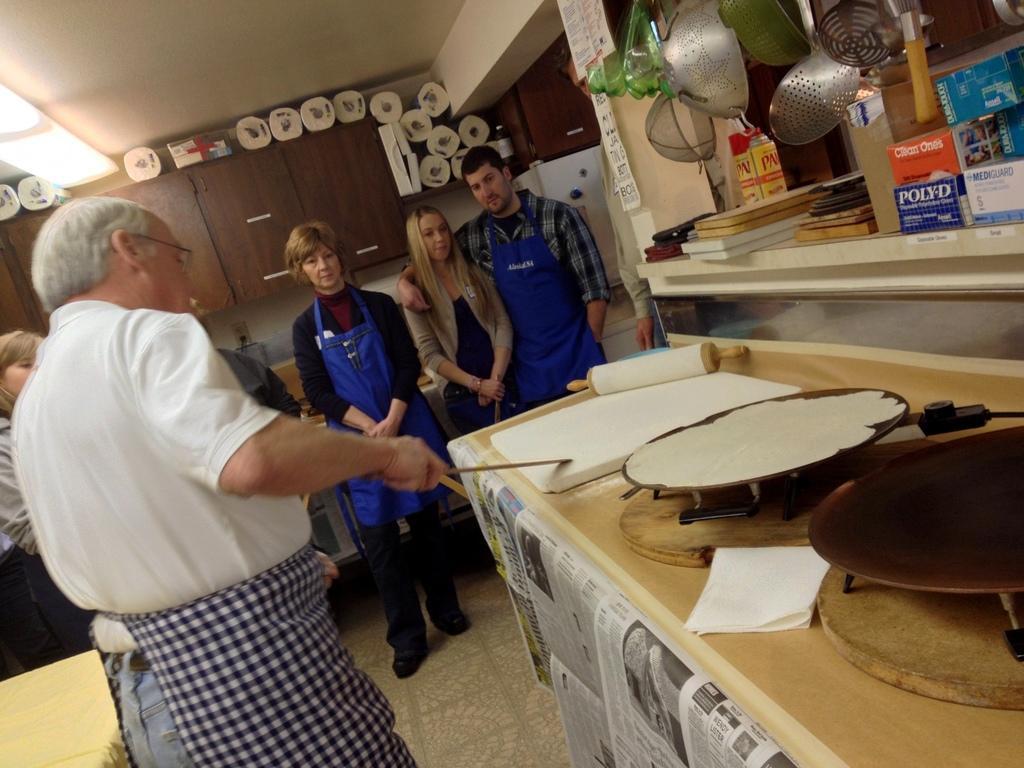Describe this image in one or two sentences. In this image ,in the middle there is a man who is standing and explaining the things to the people who are beside him. There are people wearing the cooking court. At the top there is light,cupboard and tissue papers on it. To the right side there is a pan on which there is chapati and in front of it there are steel spoons. 